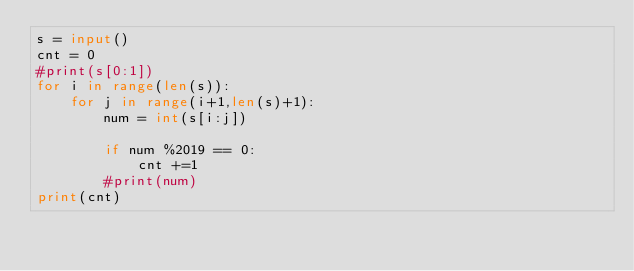Convert code to text. <code><loc_0><loc_0><loc_500><loc_500><_Python_>s = input()
cnt = 0
#print(s[0:1])
for i in range(len(s)):
    for j in range(i+1,len(s)+1):
        num = int(s[i:j])
        
        if num %2019 == 0:
            cnt +=1
        #print(num)
print(cnt)
</code> 